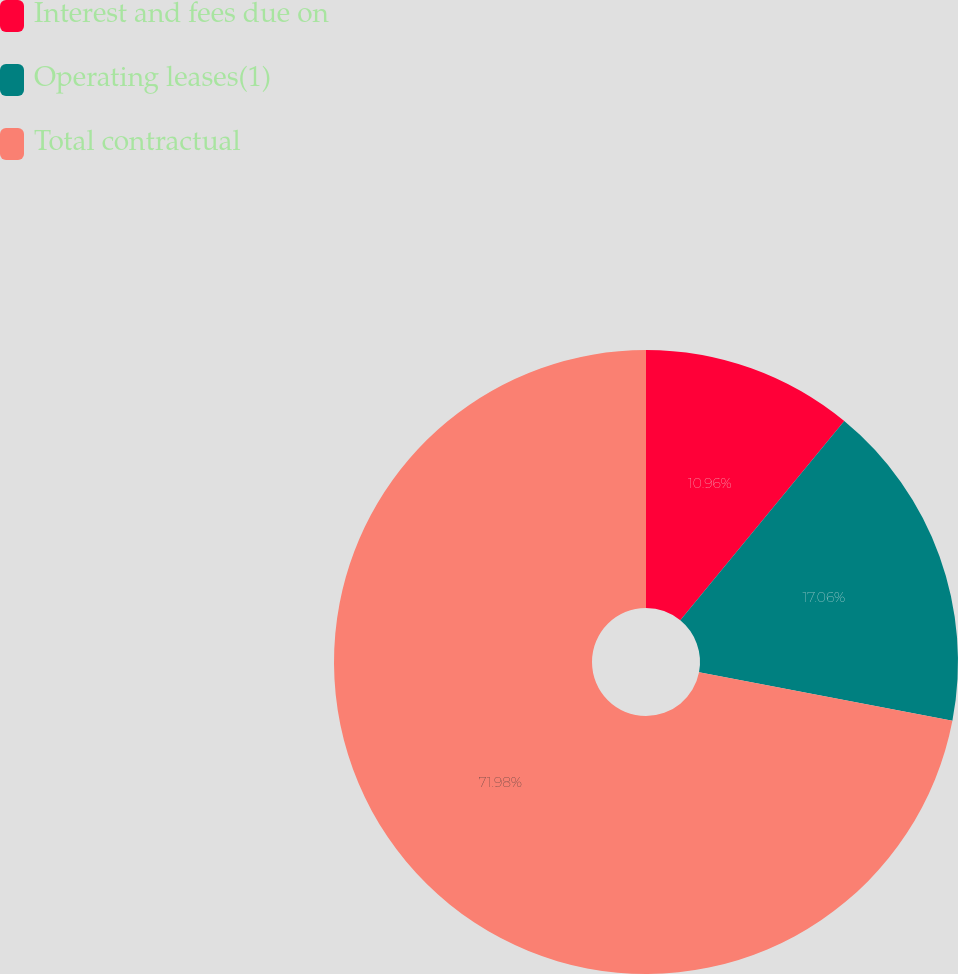Convert chart. <chart><loc_0><loc_0><loc_500><loc_500><pie_chart><fcel>Interest and fees due on<fcel>Operating leases(1)<fcel>Total contractual<nl><fcel>10.96%<fcel>17.06%<fcel>71.98%<nl></chart> 